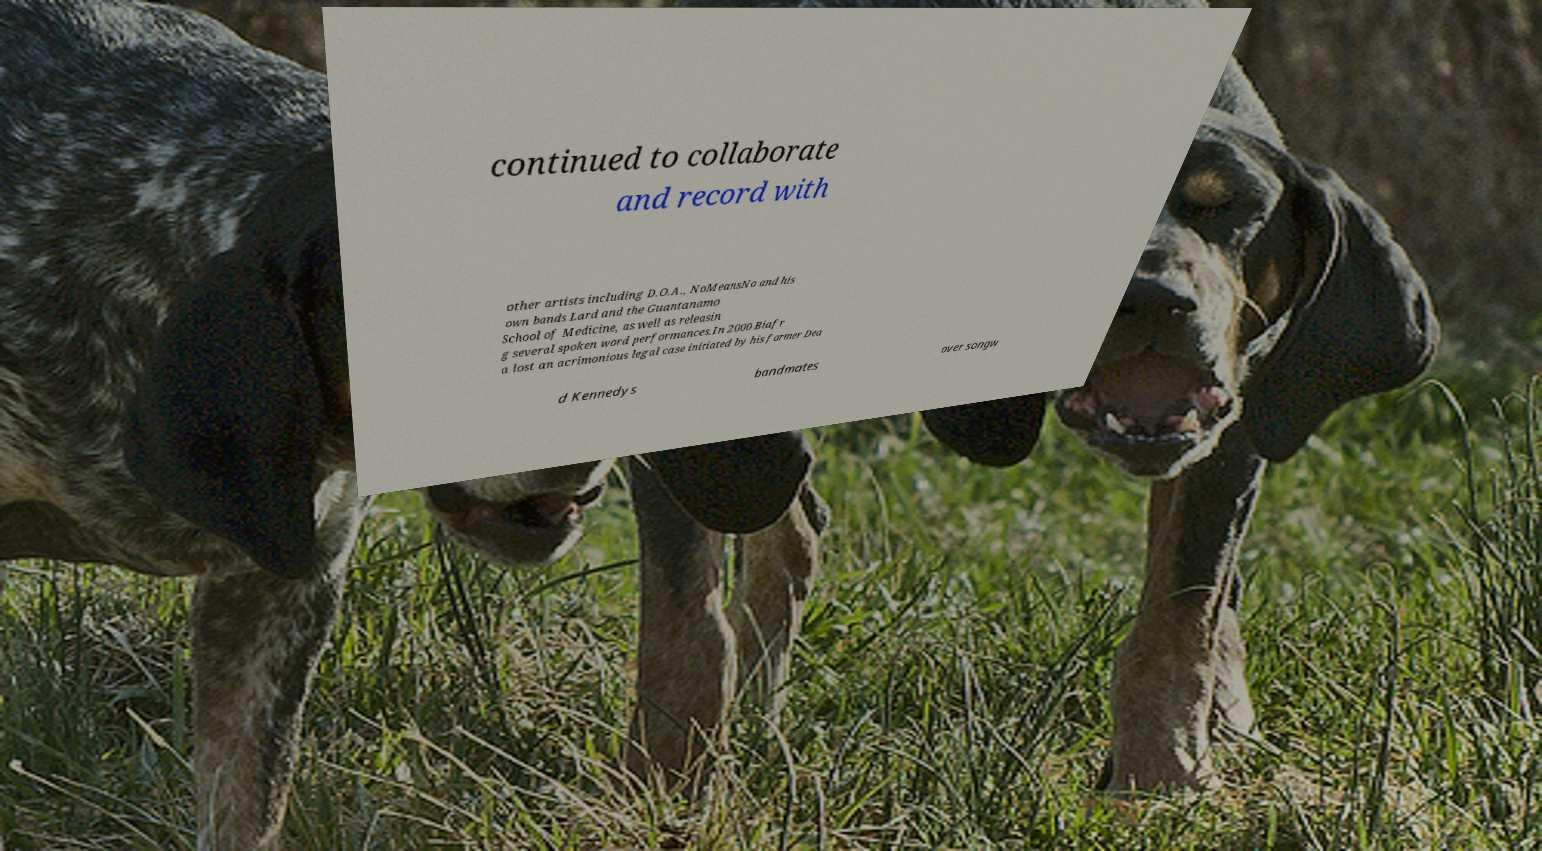Please read and relay the text visible in this image. What does it say? continued to collaborate and record with other artists including D.O.A., NoMeansNo and his own bands Lard and the Guantanamo School of Medicine, as well as releasin g several spoken word performances.In 2000 Biafr a lost an acrimonious legal case initiated by his former Dea d Kennedys bandmates over songw 